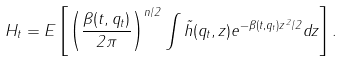Convert formula to latex. <formula><loc_0><loc_0><loc_500><loc_500>H _ { t } = E \left [ \left ( \frac { \beta ( t , q _ { t } ) } { 2 \pi } \right ) ^ { n / 2 } \int \tilde { h } ( q _ { t } , z ) e ^ { - \beta ( t , q _ { t } ) \| z \| ^ { 2 } / 2 } d z \right ] .</formula> 